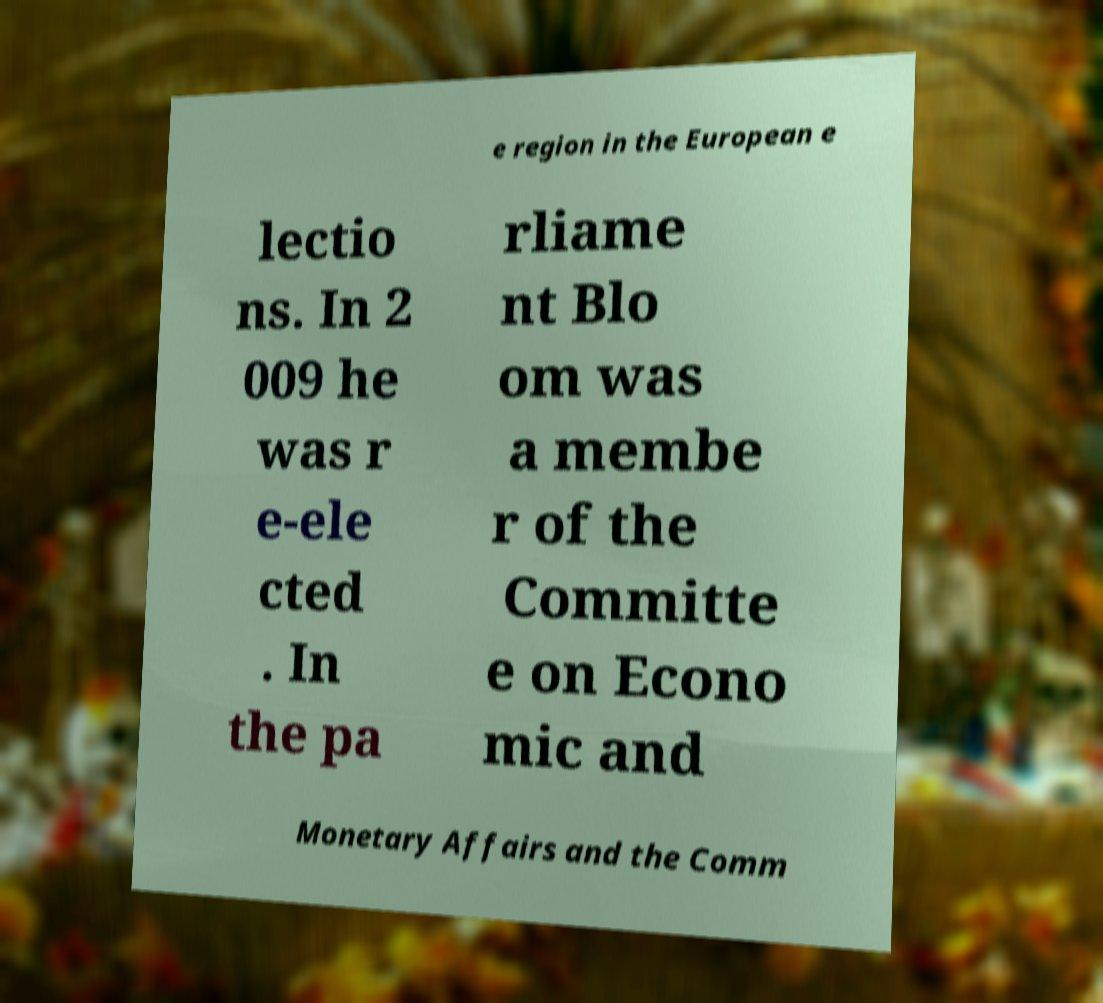Could you extract and type out the text from this image? e region in the European e lectio ns. In 2 009 he was r e-ele cted . In the pa rliame nt Blo om was a membe r of the Committe e on Econo mic and Monetary Affairs and the Comm 